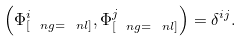<formula> <loc_0><loc_0><loc_500><loc_500>\left ( \Phi ^ { i } _ { [ \ n g = \ n l ] } , \Phi ^ { j } _ { [ \ n g = \ n l ] } \right ) = \delta ^ { i j } .</formula> 